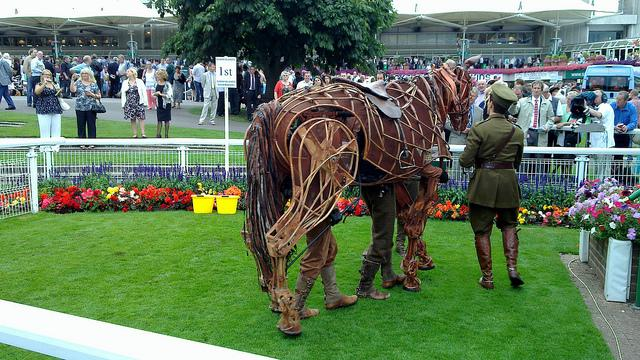What is inside of the horse sculpture? Please explain your reasoning. humans. The sculpture has people walking underneath it. 